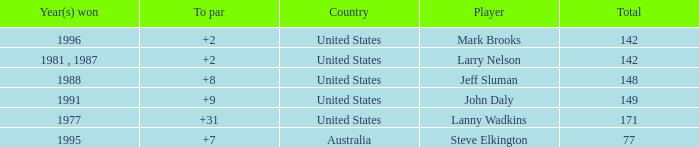Name the Total of australia and a To par smaller than 7? None. 